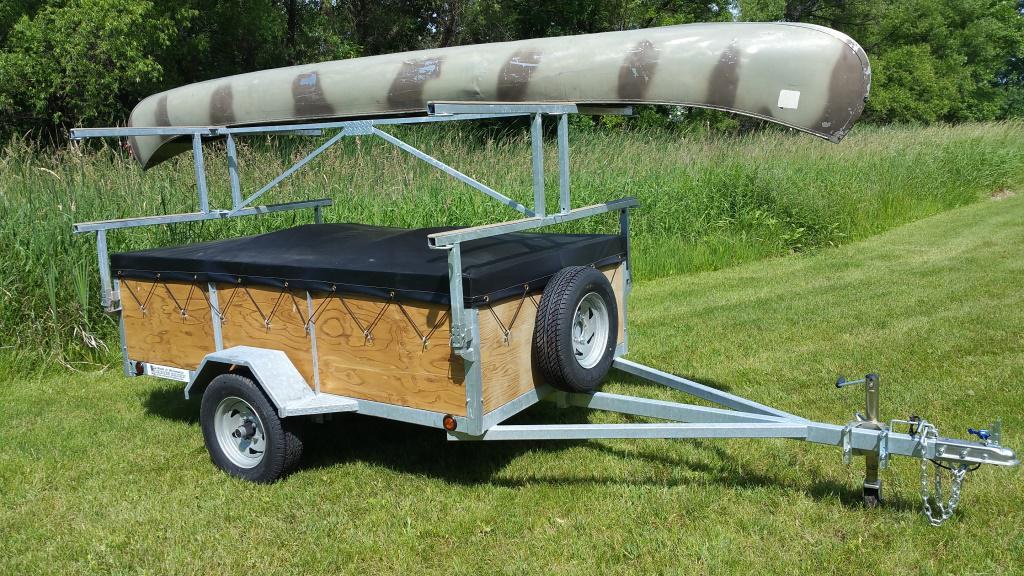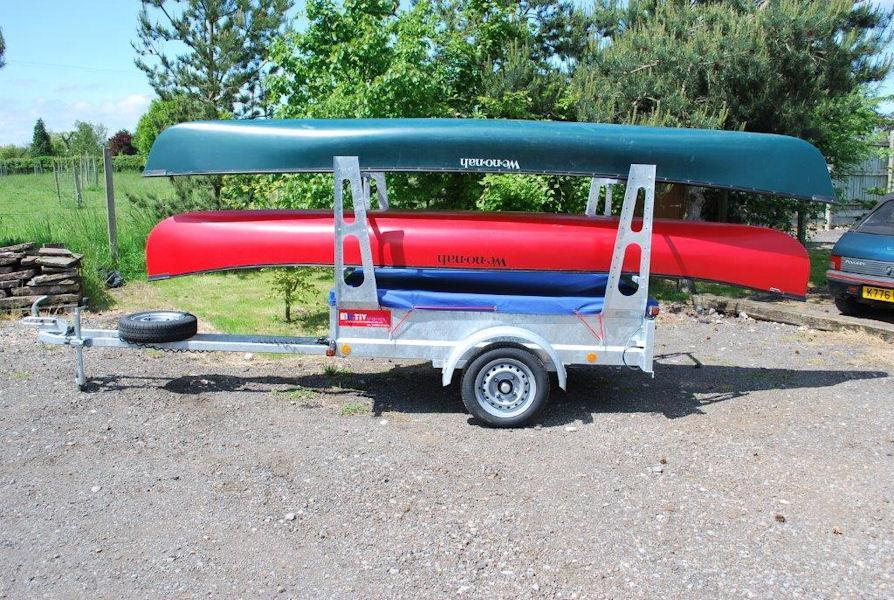The first image is the image on the left, the second image is the image on the right. Analyze the images presented: Is the assertion "There is a green canoe above a red canoe in the right image." valid? Answer yes or no. Yes. The first image is the image on the left, the second image is the image on the right. Given the left and right images, does the statement "At least one canoe is loaded onto a wooden trailer with a black cover in the image on the left." hold true? Answer yes or no. Yes. 